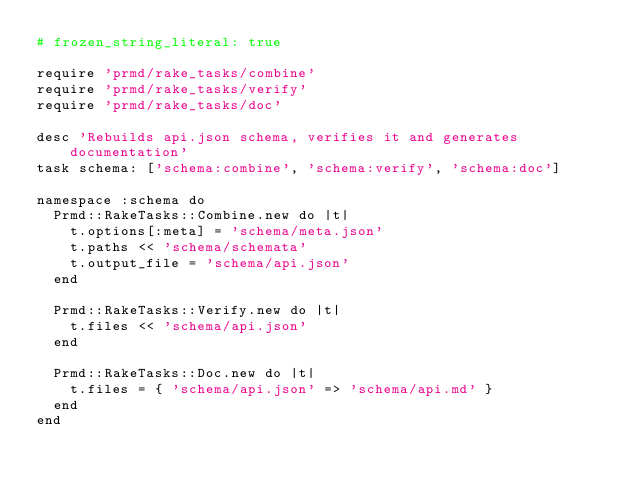<code> <loc_0><loc_0><loc_500><loc_500><_Ruby_># frozen_string_literal: true

require 'prmd/rake_tasks/combine'
require 'prmd/rake_tasks/verify'
require 'prmd/rake_tasks/doc'

desc 'Rebuilds api.json schema, verifies it and generates documentation'
task schema: ['schema:combine', 'schema:verify', 'schema:doc']

namespace :schema do
  Prmd::RakeTasks::Combine.new do |t|
    t.options[:meta] = 'schema/meta.json'
    t.paths << 'schema/schemata'
    t.output_file = 'schema/api.json'
  end

  Prmd::RakeTasks::Verify.new do |t|
    t.files << 'schema/api.json'
  end

  Prmd::RakeTasks::Doc.new do |t|
    t.files = { 'schema/api.json' => 'schema/api.md' }
  end
end
</code> 